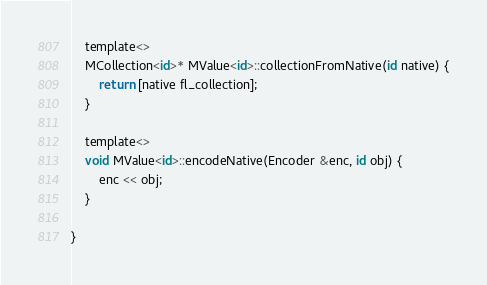<code> <loc_0><loc_0><loc_500><loc_500><_ObjectiveC_>    template<>
    MCollection<id>* MValue<id>::collectionFromNative(id native) {
        return [native fl_collection];
    }

    template<>
    void MValue<id>::encodeNative(Encoder &enc, id obj) {
        enc << obj;
    }

}

</code> 